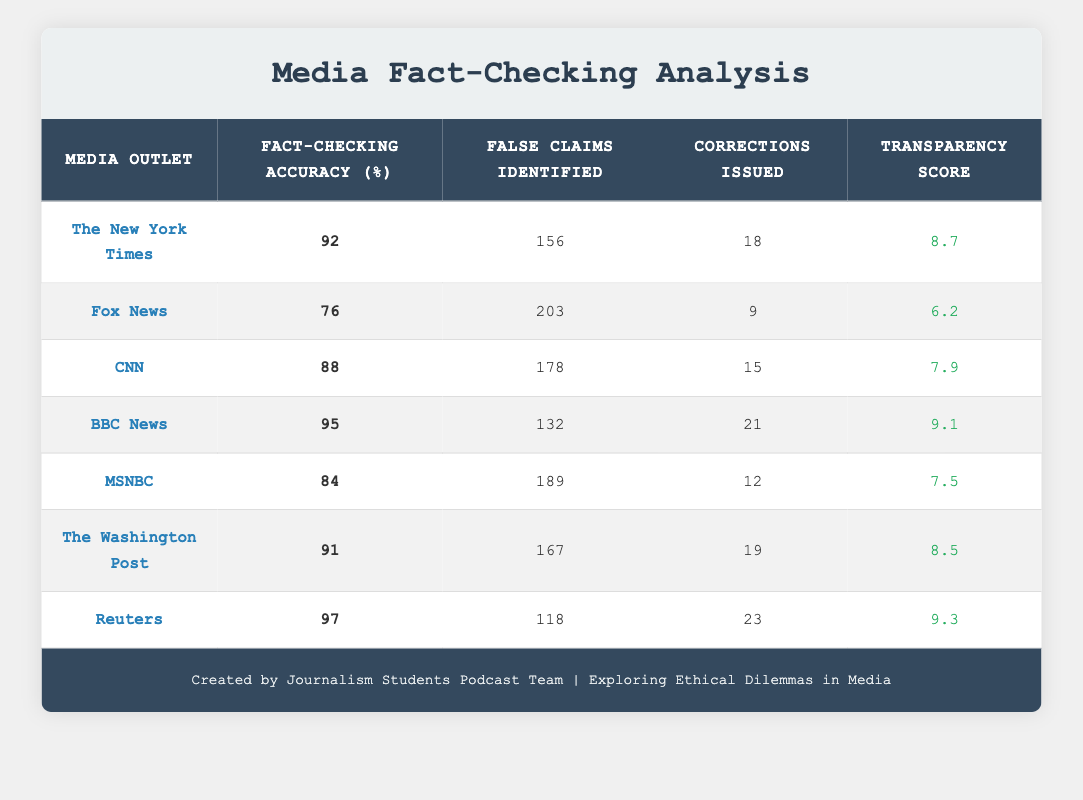What is the fact-checking accuracy of BBC News? The fact-checking accuracy for BBC News is listed directly in the table under the corresponding column, which shows a value of 95%.
Answer: 95% Which media outlet identified the most false claims? By reviewing the "False Claims Identified" column, it is evident that Fox News has the highest number with 203 false claims identified.
Answer: Fox News What is the average fact-checking accuracy of the media outlets listed? To find the average, first sum the accuracy values: 92 + 76 + 88 + 95 + 84 + 91 + 97 = 623. There are 7 media outlets, so the average is 623 / 7, which equals roughly 89.
Answer: 89 Does CNN have a lower fact-checking accuracy than MSNBC? When comparing CNN’s accuracy of 88% with MSNBC’s accuracy of 84%, it is clear that CNN is higher. Therefore, the statement is false.
Answer: No Which outlet has the highest transparency score? Looking at the transparency scores, Reuters has the highest value listed at 9.3. This can be confirmed directly from the table.
Answer: Reuters How many corrections were issued by The Washington Post? The number of corrections issued by The Washington Post is indicated in the table, which notes that they issued 19 corrections.
Answer: 19 What is the difference in transparency scores between The New York Times and Fox News? The transparency score for The New York Times is 8.7 and for Fox News is 6.2. The difference is calculated by subtracting Fox News' score from The New York Times' score: 8.7 - 6.2 = 2.5.
Answer: 2.5 Is it true that The New York Times issued more corrections than MSNBC? The New York Times issued 18 corrections while MSNBC issued 12 corrections. Since 18 is greater than 12, the statement is true.
Answer: Yes Which media outlet has a fact-checking accuracy within 10% of Reuters? Reuters has an accuracy of 97%. Returning to other outlet values, BBC News has 95%, which is within 10% of Reuters’ accuracy (7% difference). Other outlets do not fall within this range.
Answer: BBC News 